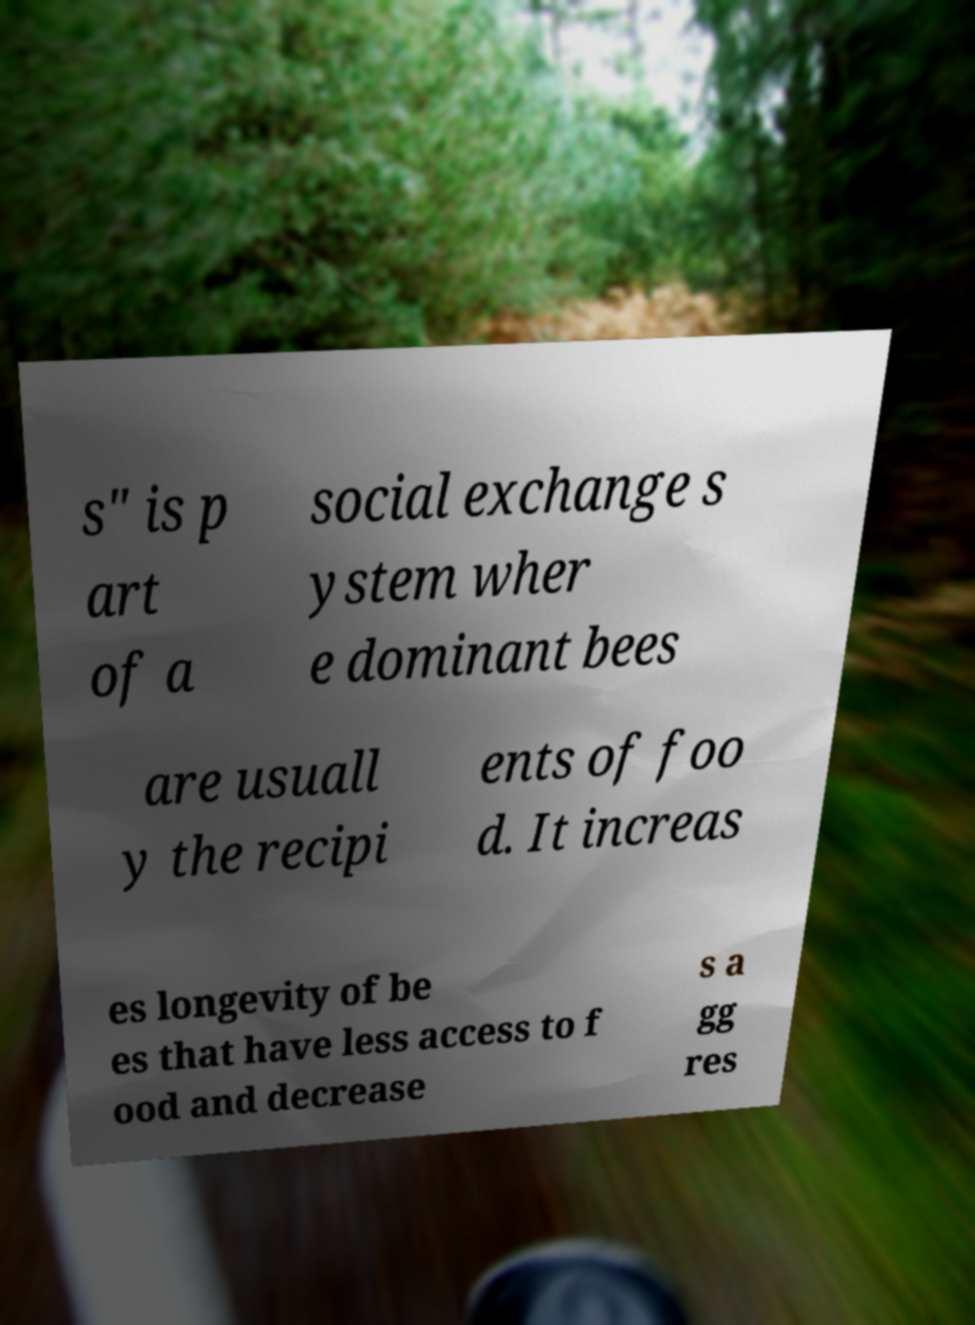Could you extract and type out the text from this image? s" is p art of a social exchange s ystem wher e dominant bees are usuall y the recipi ents of foo d. It increas es longevity of be es that have less access to f ood and decrease s a gg res 